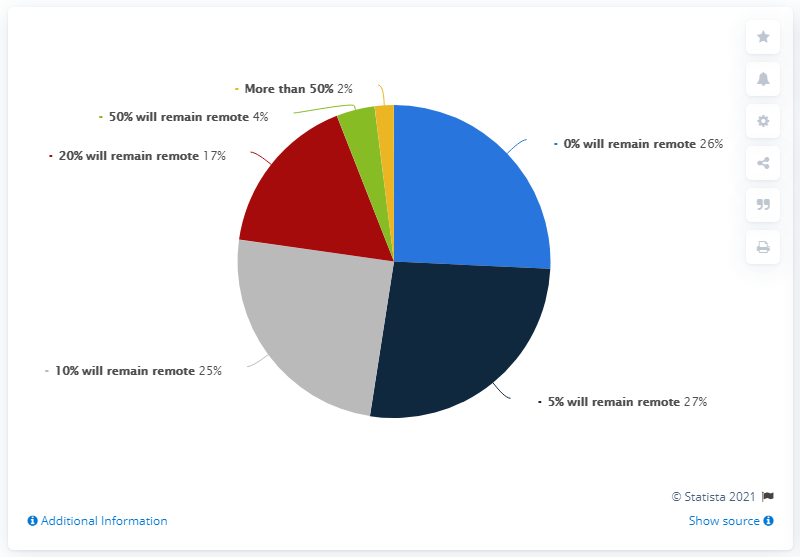Indicate a few pertinent items in this graphic. The ratio of the smallest and green segments in A:B is 0.5. The smallest segment is yellow in color. 